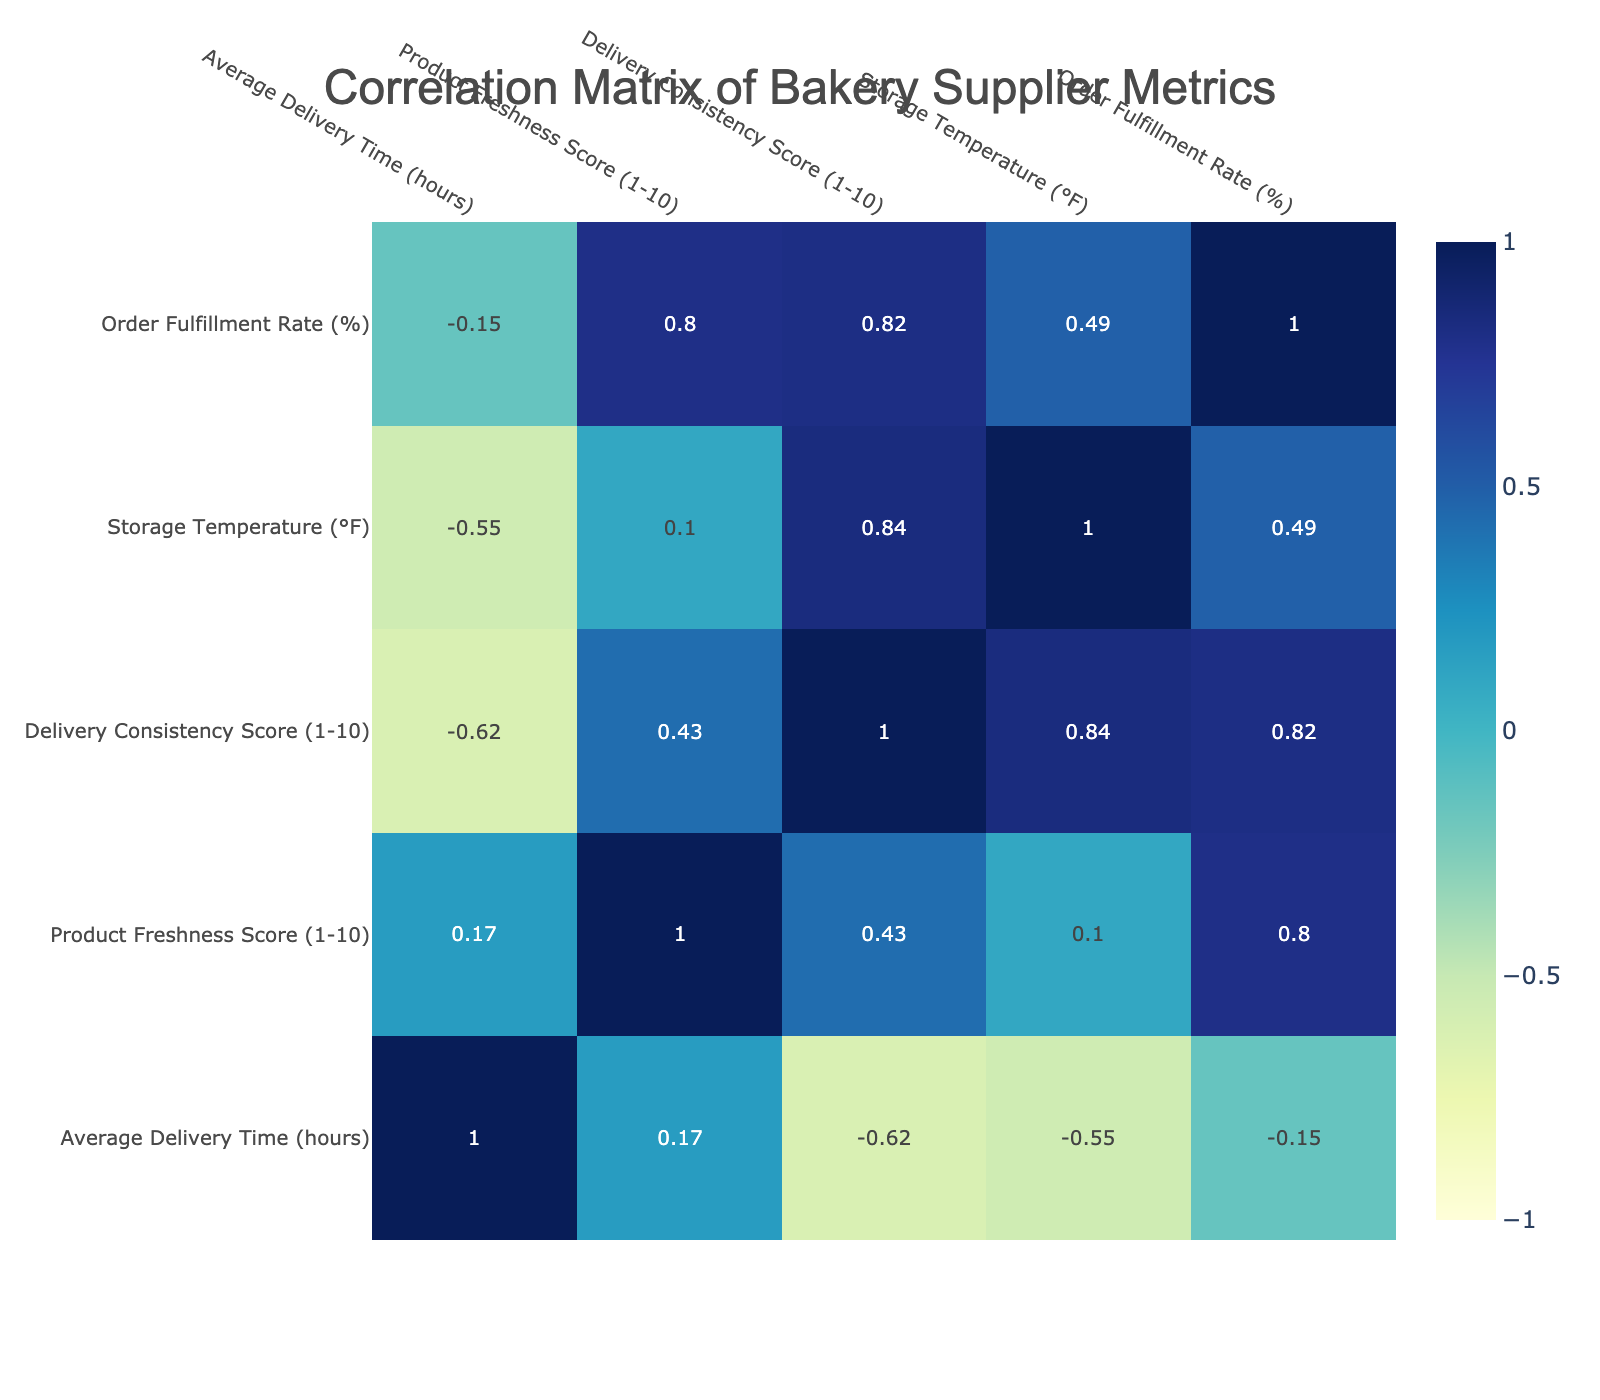What is the Product Freshness Score for QualityGrains? The table shows that the Product Freshness Score for QualityGrains is listed as 6.
Answer: 6 Which supplier has the highest Delivery Consistency Score? By checking the Delivery Consistency Score column, SweetSuccess Ingredients has the highest score of 8.
Answer: SweetSuccess Ingredients What is the correlation between Average Delivery Time and Product Freshness Score? The correlation matrix reflects a negative correlation between Average Delivery Time and Product Freshness Score, indicating that as delivery time increases, freshness score tends to decrease.
Answer: Negative correlation What is the average Order Fulfillment Rate for suppliers with a Product Freshness Score greater than 8? The suppliers with a freshness score greater than 8 are FreshBakers Supply, SweetSuccess Ingredients, and LocalFlour Co. Their fulfillment rates are 95, 92, and 87 respectively. The average is (95 + 92 + 87) / 3 = 91.33.
Answer: 91.33 Is there a supplier with an Average Delivery Time of less than 15 hours? Looking through the Average Delivery Time column, QualityGrains is the only supplier with a time of 10 hours, confirming that there is at least one supplier with a delivery time under 15 hours.
Answer: Yes Which supplier has the lowest Product Freshness Score and what is it? From the table, ArtisanBakery Supplies has the lowest Product Freshness Score listed as 5.
Answer: ArtisanBakery Supplies, 5 How does the Average Delivery Time relate to Delivery Consistency Score for suppliers with a freshness score of 6? Both Baker's Best Supply and QualityGrains have a Product Freshness Score of 6. Their average delivery times are (18 + 10) / 2 = 14 hours, and their Delivery Consistency Scores are (6 + 9) / 2 = 7.5, showing that lower freshness correlates with a lower consistency score.
Answer: Average Delivery Time: 14 hours, Consistency Score: 7.5 Which storage temperature is associated with the highest Product Freshness Score and what is that score? Analyzing the table, FreshBakers Supply has the highest freshness score at 9, and its corresponding storage temperature is 38°F.
Answer: 38°F, 9 